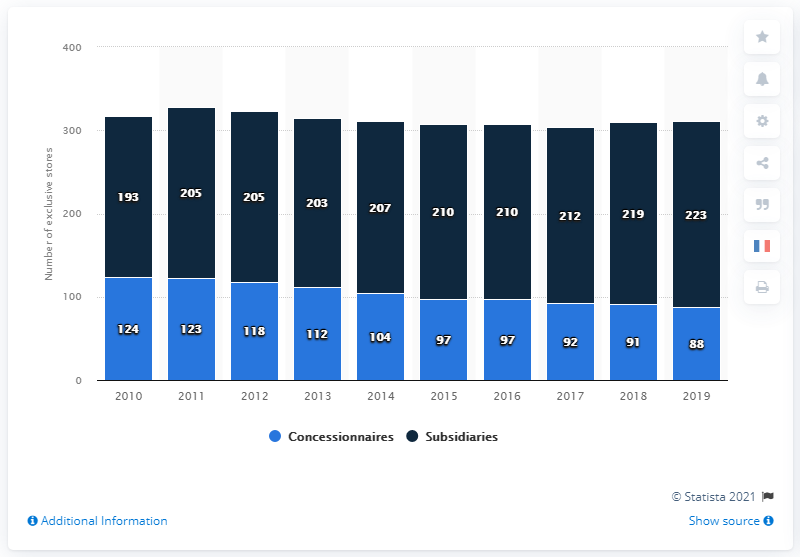Indicate a few pertinent items in this graphic. There were 97 concessionaires between 2015 and 2016. 